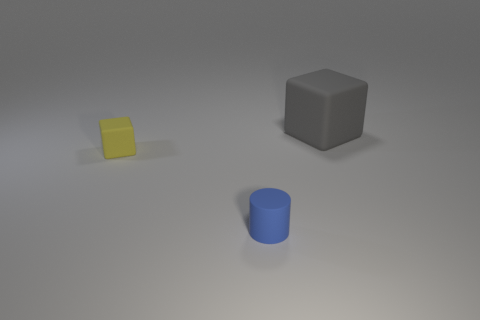What is the size of the block in front of the matte object that is behind the block that is in front of the large block?
Ensure brevity in your answer.  Small. The gray rubber thing is what size?
Offer a very short reply. Large. Is there anything else that has the same material as the blue object?
Your response must be concise. Yes. Is there a rubber cube behind the rubber thing that is behind the tiny object behind the cylinder?
Your answer should be compact. No. How many big objects are either purple metallic cylinders or yellow rubber blocks?
Make the answer very short. 0. Is there anything else of the same color as the small cube?
Make the answer very short. No. There is a block that is left of the gray thing; is it the same size as the blue cylinder?
Offer a terse response. Yes. There is a small thing behind the small blue matte cylinder that is on the right side of the cube that is in front of the big object; what color is it?
Your response must be concise. Yellow. The large matte cube is what color?
Your response must be concise. Gray. Do the small matte cube and the matte cylinder have the same color?
Keep it short and to the point. No. 